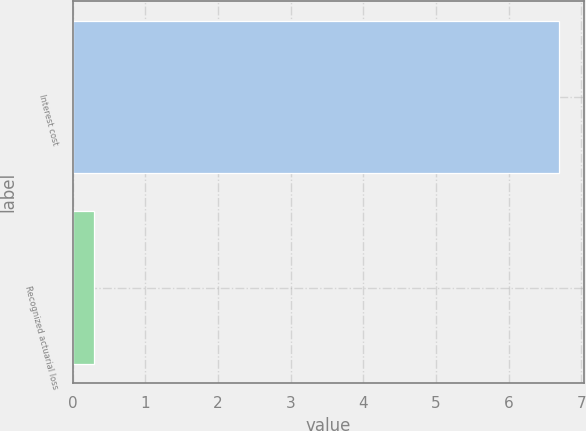Convert chart to OTSL. <chart><loc_0><loc_0><loc_500><loc_500><bar_chart><fcel>Interest cost<fcel>Recognized actuarial loss<nl><fcel>6.7<fcel>0.3<nl></chart> 